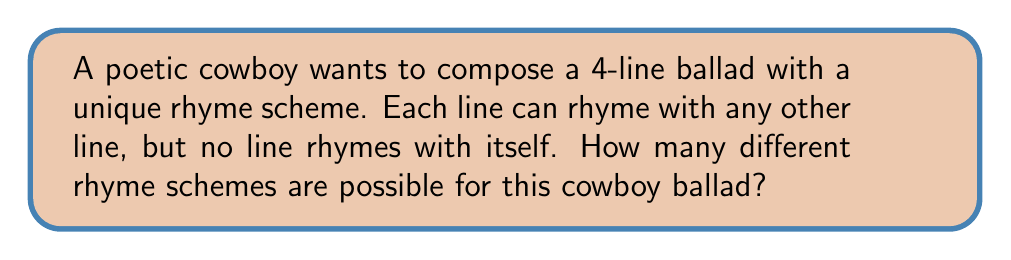Can you answer this question? Let's approach this step-by-step:

1) We can represent the rhyme scheme using letters, where lines that rhyme share the same letter.

2) For a 4-line ballad, we need to consider partitions of the set {1, 2, 3, 4}.

3) The possible partitions are:
   - AAAA (all lines rhyme) - not allowed as no line rhymes with itself
   - AAAB, AABA, ABAA, BAAA (3 lines rhyme, 1 doesn't)
   - AABB, ABBA, ABAB (2 pairs of rhyming lines)
   - AABC, ABAC, ABCA, BAAC, BACA, BCAA (2 lines rhyme, 2 don't)
   - ABCD (no lines rhyme)

4) Now, let's count the valid schemes:
   - AAAB type: 4 schemes
   - AABB type: 3 schemes
   - AABC type: 6 schemes
   - ABCD type: 1 scheme

5) Total number of possible rhyme schemes:
   $$ 4 + 3 + 6 + 1 = 14 $$

Therefore, there are 14 possible rhyme schemes for the cowboy's 4-line ballad.
Answer: 14 